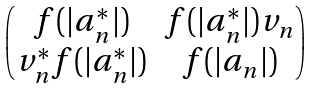Convert formula to latex. <formula><loc_0><loc_0><loc_500><loc_500>\begin{pmatrix} f ( | a _ { n } ^ { * } | ) & f ( | a _ { n } ^ { * } | ) v _ { n } \\ v _ { n } ^ { * } f ( | a _ { n } ^ { * } | ) & f ( | a _ { n } | ) \end{pmatrix}</formula> 